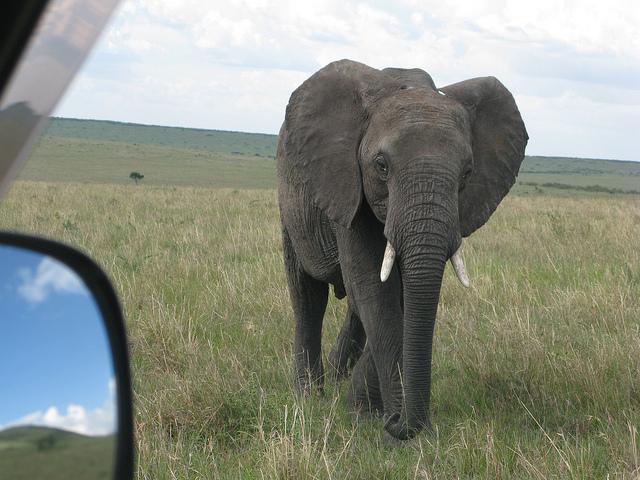What time of day is it in the photo?
Be succinct. Afternoon. What are the elephants walking on?
Give a very brief answer. Grass. How many tusk does this elephant have?
Write a very short answer. 2. How did the person get such a close up picture of the elephant?
Give a very brief answer. Safari. 